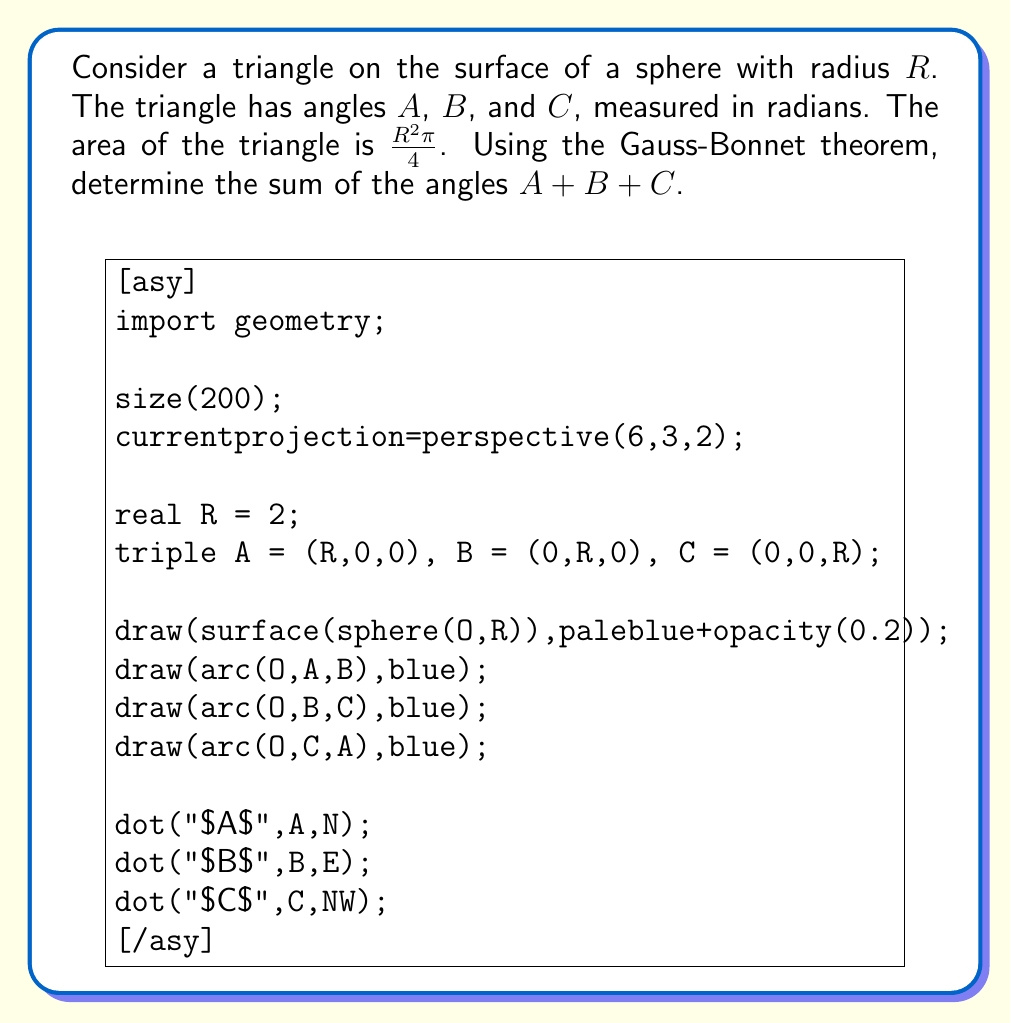Show me your answer to this math problem. Let's approach this step-by-step:

1) The Gauss-Bonnet theorem for a triangle on a sphere states:

   $A + B + C = \pi + \frac{Area}{R^2}$

   Where $A$, $B$, and $C$ are the angles of the triangle, $Area$ is the area of the triangle, and $R$ is the radius of the sphere.

2) We are given that the area of the triangle is $\frac{R^2\pi}{4}$.

3) Substituting this into the Gauss-Bonnet formula:

   $A + B + C = \pi + \frac{\frac{R^2\pi}{4}}{R^2}$

4) Simplifying the right side:

   $A + B + C = \pi + \frac{\pi}{4}$

5) We can write this as a single fraction:

   $A + B + C = \frac{4\pi}{4} + \frac{\pi}{4} = \frac{5\pi}{4}$

Thus, the sum of the angles in this spherical triangle is $\frac{5\pi}{4}$ radians.
Answer: $\frac{5\pi}{4}$ radians 